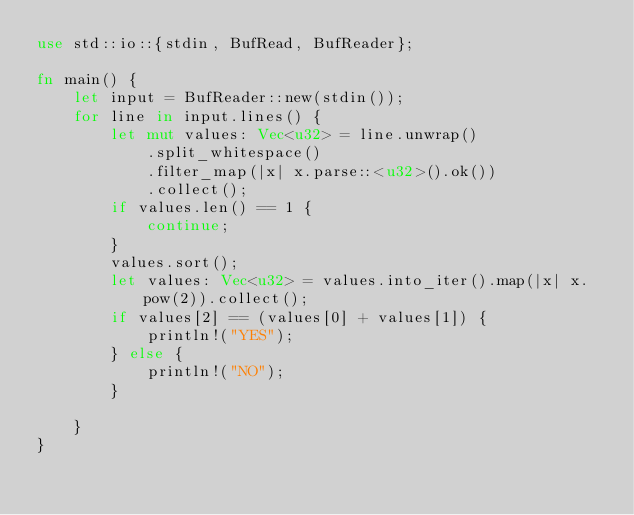Convert code to text. <code><loc_0><loc_0><loc_500><loc_500><_Rust_>use std::io::{stdin, BufRead, BufReader};

fn main() {
    let input = BufReader::new(stdin());
    for line in input.lines() {
        let mut values: Vec<u32> = line.unwrap()
            .split_whitespace()
            .filter_map(|x| x.parse::<u32>().ok())
            .collect();
        if values.len() == 1 {
            continue;
        }
        values.sort();
        let values: Vec<u32> = values.into_iter().map(|x| x.pow(2)).collect();
        if values[2] == (values[0] + values[1]) {
            println!("YES");
        } else {
            println!("NO");
        }

    }
}

</code> 